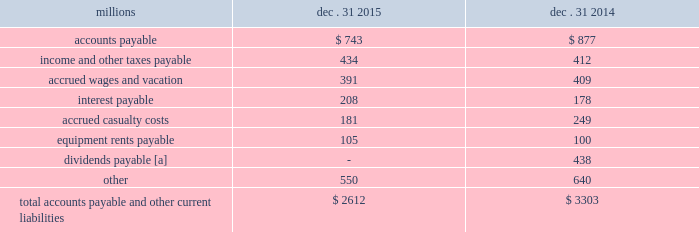Appropriate statistical bases .
Total expense for repairs and maintenance incurred was $ 2.5 billion for 2015 , $ 2.4 billion for 2014 , and $ 2.3 billion for 2013 .
Assets held under capital leases are recorded at the lower of the net present value of the minimum lease payments or the fair value of the leased asset at the inception of the lease .
Amortization expense is computed using the straight-line method over the shorter of the estimated useful lives of the assets or the period of the related lease .
13 .
Accounts payable and other current liabilities dec .
31 , dec .
31 , millions 2015 2014 .
[a] beginning in 2015 , the timing of the dividend declaration and payable dates was aligned to occur within the same quarter .
The 2015 dividends paid amount includes the fourth quarter 2014 dividend of $ 438 million , which was paid on january 2 , 2015 , the first quarter 2015 dividend of $ 484 million , which was paid on march 30 , 2015 , the second quarter 2015 dividend of $ 479 million , which was paid on june 30 , 2015 , the third quarter 2015 dividend of $ 476 million , which was paid on september 30 , 2015 , as well as the fourth quarter 2015 dividend of $ 467 million , which was paid on december 30 , 2015 .
14 .
Financial instruments strategy and risk 2013 we may use derivative financial instruments in limited instances for other than trading purposes to assist in managing our overall exposure to fluctuations in interest rates and fuel prices .
We are not a party to leveraged derivatives and , by policy , do not use derivative financial instruments for speculative purposes .
Derivative financial instruments qualifying for hedge accounting must maintain a specified level of effectiveness between the hedging instrument and the item being hedged , both at inception and throughout the hedged period .
We formally document the nature and relationships between the hedging instruments and hedged items at inception , as well as our risk- management objectives , strategies for undertaking the various hedge transactions , and method of assessing hedge effectiveness .
Changes in the fair market value of derivative financial instruments that do not qualify for hedge accounting are charged to earnings .
We may use swaps , collars , futures , and/or forward contracts to mitigate the risk of adverse movements in interest rates and fuel prices ; however , the use of these derivative financial instruments may limit future benefits from favorable interest rate and fuel price movements .
Market and credit risk 2013 we address market risk related to derivative financial instruments by selecting instruments with value fluctuations that highly correlate with the underlying hedged item .
We manage credit risk related to derivative financial instruments , which is minimal , by requiring high credit standards for counterparties and periodic settlements .
At december 31 , 2015 , and 2014 , we were not required to provide collateral , nor had we received collateral , relating to our hedging activities .
Interest rate fair value hedges 2013 we manage our overall exposure to fluctuations in interest rates by adjusting the proportion of fixed and floating rate debt instruments within our debt portfolio over a given period .
We generally manage the mix of fixed and floating rate debt through the issuance of targeted amounts of each as debt matures or as we require incremental borrowings .
We employ derivatives , primarily swaps , as one of the tools to obtain the targeted mix .
In addition , we also obtain flexibility in managing interest costs and the interest rate mix within our debt portfolio by evaluating the issuance of and managing outstanding callable fixed-rate debt securities .
Swaps allow us to convert debt from fixed rates to variable rates and thereby hedge the risk of changes in the debt 2019s fair value attributable to the changes in interest rates .
We account for swaps as fair value hedges using the short-cut method ; therefore , we do not record any ineffectiveness within our .
What was the percentage change in equipment rents payable from 2014 to 2015? 
Computations: ((105 - 100) / 100)
Answer: 0.05. 